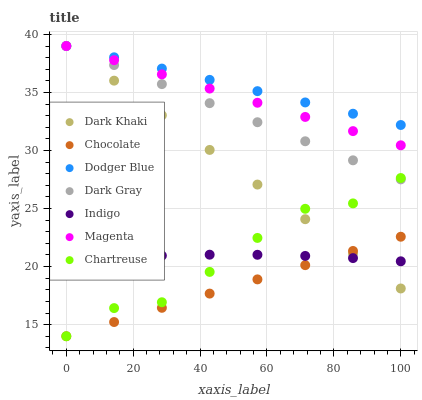Does Chocolate have the minimum area under the curve?
Answer yes or no. Yes. Does Dodger Blue have the maximum area under the curve?
Answer yes or no. Yes. Does Indigo have the minimum area under the curve?
Answer yes or no. No. Does Indigo have the maximum area under the curve?
Answer yes or no. No. Is Dodger Blue the smoothest?
Answer yes or no. Yes. Is Chartreuse the roughest?
Answer yes or no. Yes. Is Indigo the smoothest?
Answer yes or no. No. Is Indigo the roughest?
Answer yes or no. No. Does Chocolate have the lowest value?
Answer yes or no. Yes. Does Indigo have the lowest value?
Answer yes or no. No. Does Magenta have the highest value?
Answer yes or no. Yes. Does Chocolate have the highest value?
Answer yes or no. No. Is Indigo less than Magenta?
Answer yes or no. Yes. Is Dark Gray greater than Indigo?
Answer yes or no. Yes. Does Chartreuse intersect Indigo?
Answer yes or no. Yes. Is Chartreuse less than Indigo?
Answer yes or no. No. Is Chartreuse greater than Indigo?
Answer yes or no. No. Does Indigo intersect Magenta?
Answer yes or no. No. 